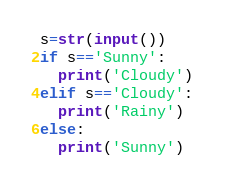<code> <loc_0><loc_0><loc_500><loc_500><_Python_>s=str(input())
if s=='Sunny':
  print('Cloudy')
elif s=='Cloudy':
  print('Rainy')  
else:
  print('Sunny')</code> 